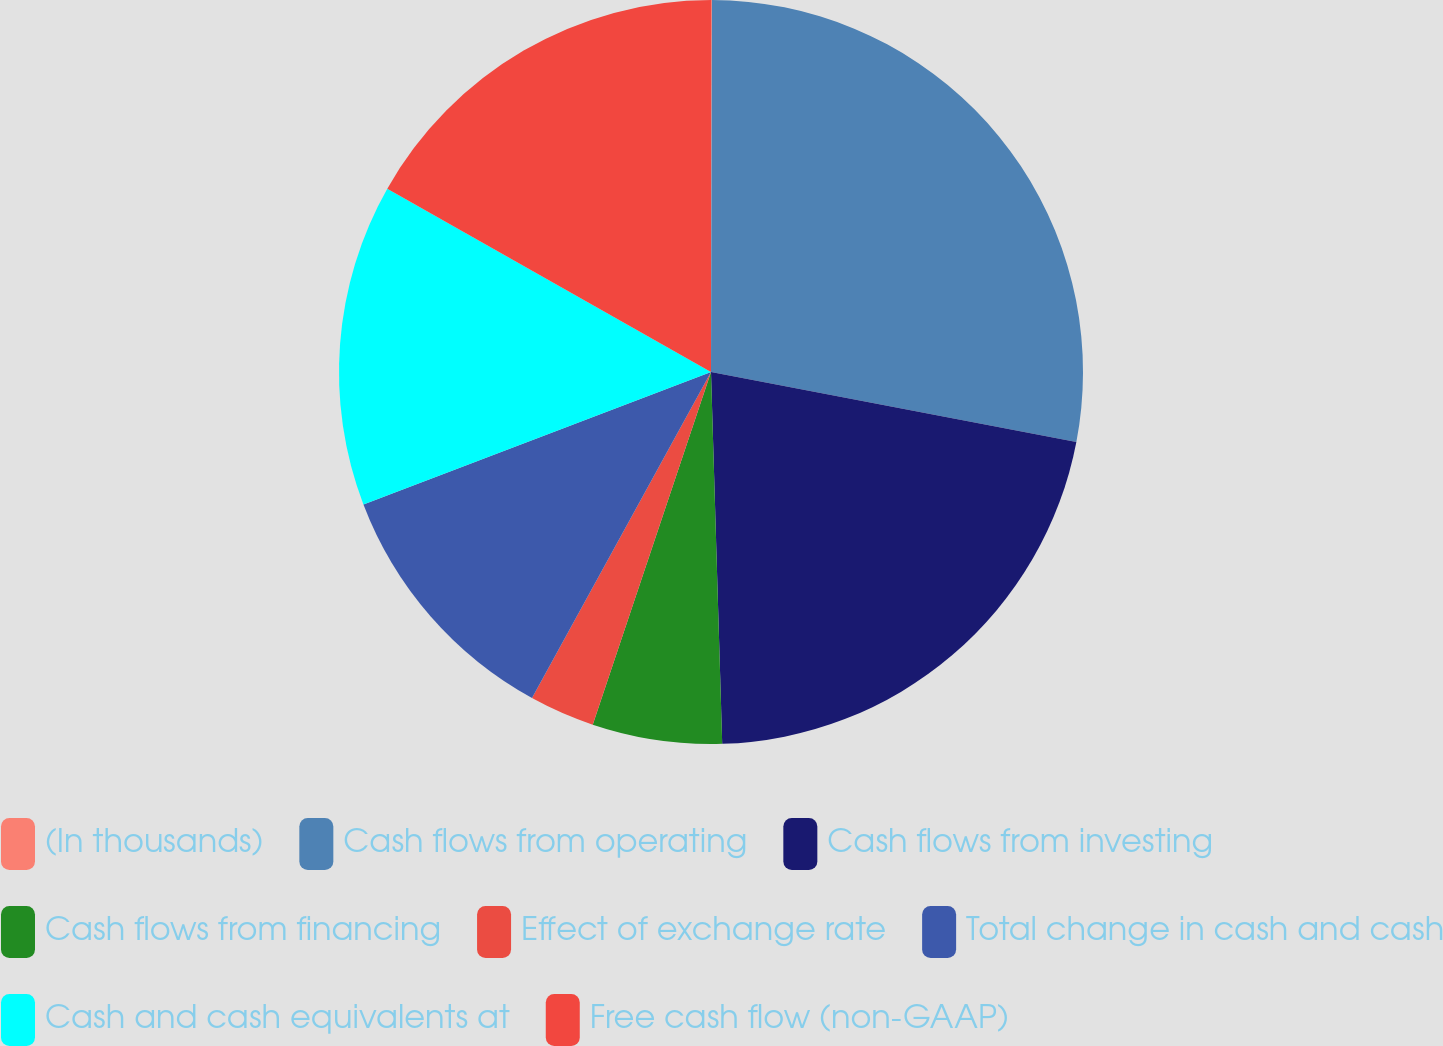Convert chart. <chart><loc_0><loc_0><loc_500><loc_500><pie_chart><fcel>(In thousands)<fcel>Cash flows from operating<fcel>Cash flows from investing<fcel>Cash flows from financing<fcel>Effect of exchange rate<fcel>Total change in cash and cash<fcel>Cash and cash equivalents at<fcel>Free cash flow (non-GAAP)<nl><fcel>0.04%<fcel>27.97%<fcel>21.51%<fcel>5.63%<fcel>2.84%<fcel>11.21%<fcel>14.0%<fcel>16.8%<nl></chart> 